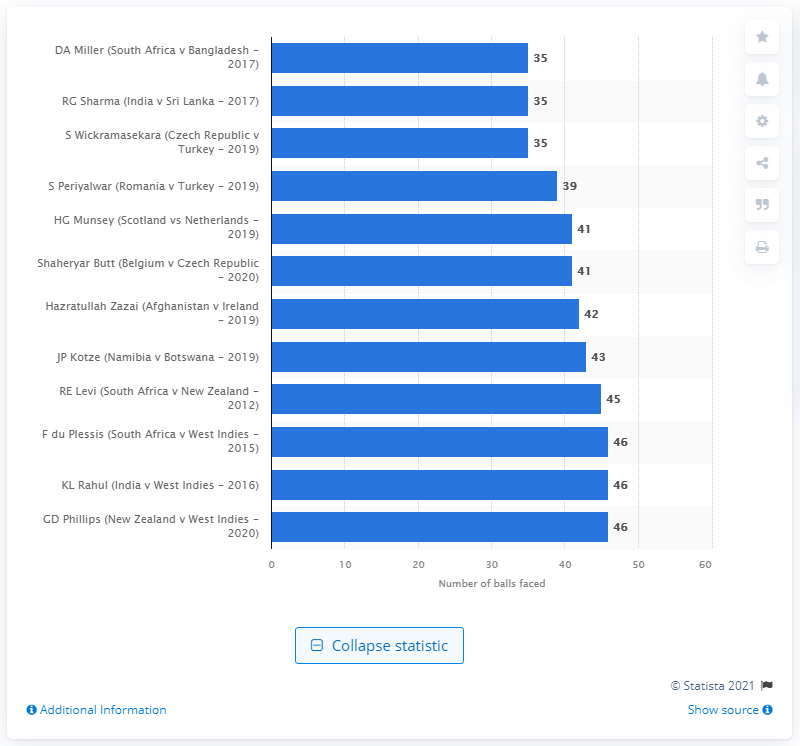Outline some significant characteristics in this image. David Miller achieved the fastest international T20 century of all time by taking just 35 balls, answering the question of how many he took in his remarkable performance. 